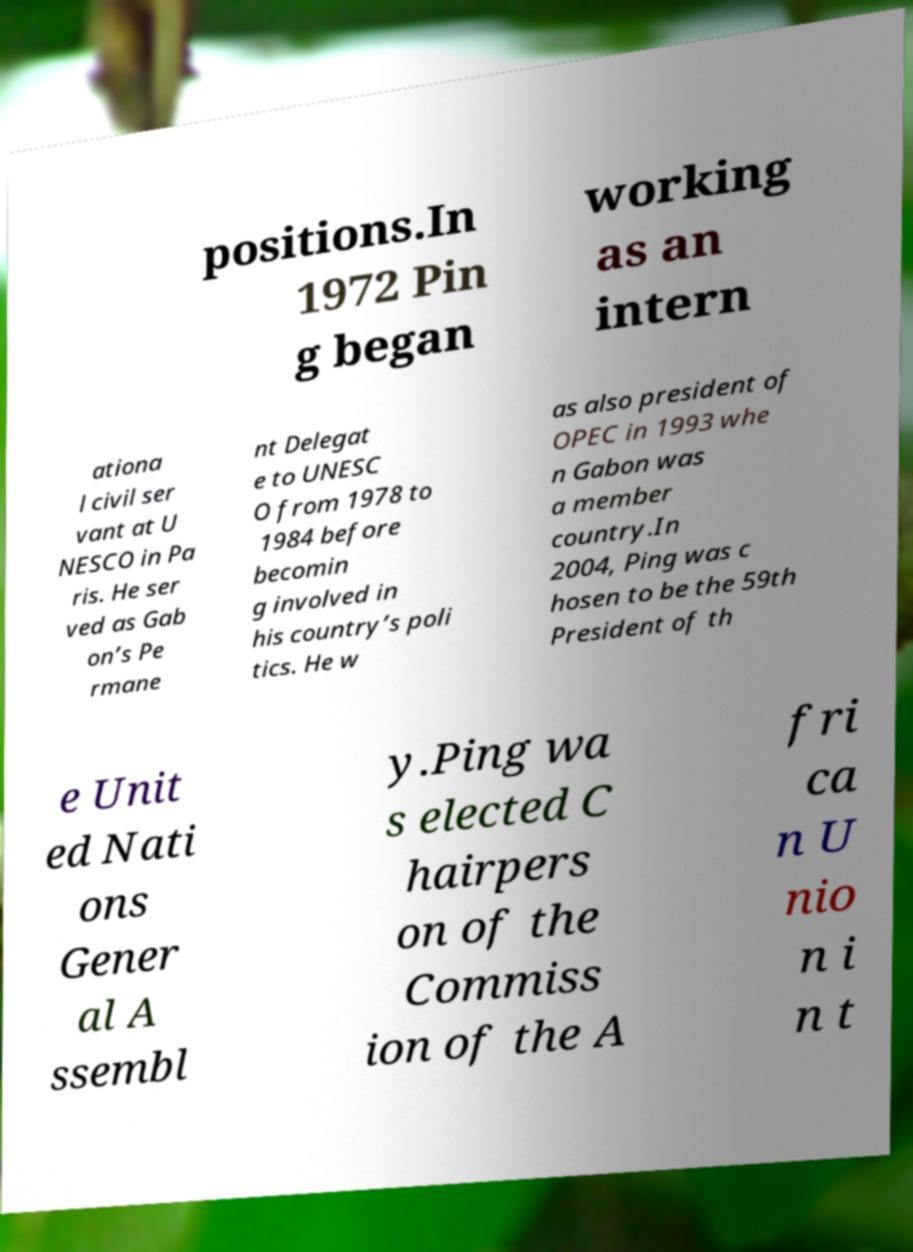Please read and relay the text visible in this image. What does it say? positions.In 1972 Pin g began working as an intern ationa l civil ser vant at U NESCO in Pa ris. He ser ved as Gab on’s Pe rmane nt Delegat e to UNESC O from 1978 to 1984 before becomin g involved in his country’s poli tics. He w as also president of OPEC in 1993 whe n Gabon was a member country.In 2004, Ping was c hosen to be the 59th President of th e Unit ed Nati ons Gener al A ssembl y.Ping wa s elected C hairpers on of the Commiss ion of the A fri ca n U nio n i n t 